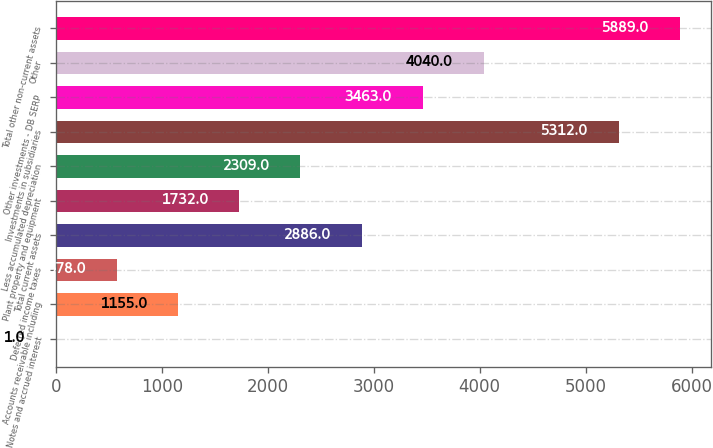<chart> <loc_0><loc_0><loc_500><loc_500><bar_chart><fcel>Notes and accrued interest<fcel>Accounts receivable including<fcel>Deferred income taxes<fcel>Total current assets<fcel>Plant property and equipment<fcel>Less accumulated depreciation<fcel>Investments in subsidiaries<fcel>Other investments - DB SERP<fcel>Other<fcel>Total other non-current assets<nl><fcel>1<fcel>1155<fcel>578<fcel>2886<fcel>1732<fcel>2309<fcel>5312<fcel>3463<fcel>4040<fcel>5889<nl></chart> 